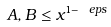Convert formula to latex. <formula><loc_0><loc_0><loc_500><loc_500>A , B \leq x ^ { 1 - \ e p s }</formula> 